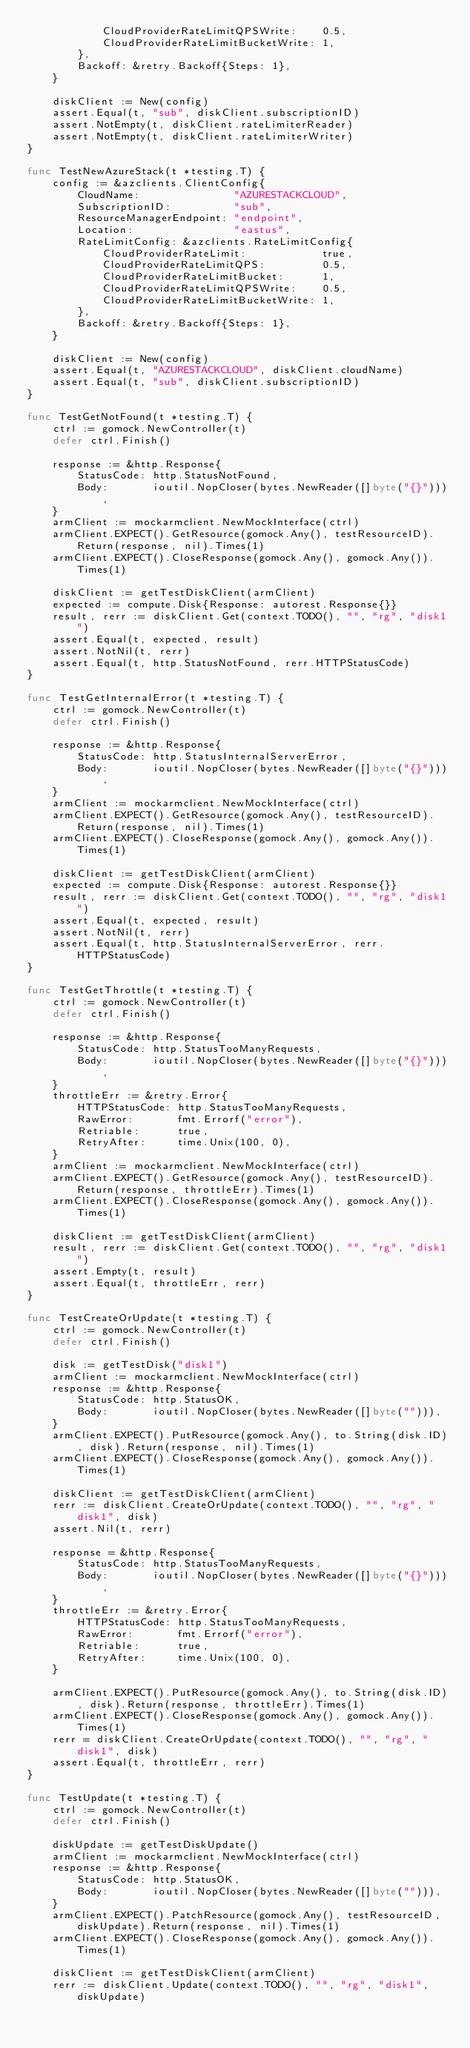<code> <loc_0><loc_0><loc_500><loc_500><_Go_>			CloudProviderRateLimitQPSWrite:    0.5,
			CloudProviderRateLimitBucketWrite: 1,
		},
		Backoff: &retry.Backoff{Steps: 1},
	}

	diskClient := New(config)
	assert.Equal(t, "sub", diskClient.subscriptionID)
	assert.NotEmpty(t, diskClient.rateLimiterReader)
	assert.NotEmpty(t, diskClient.rateLimiterWriter)
}

func TestNewAzureStack(t *testing.T) {
	config := &azclients.ClientConfig{
		CloudName:               "AZURESTACKCLOUD",
		SubscriptionID:          "sub",
		ResourceManagerEndpoint: "endpoint",
		Location:                "eastus",
		RateLimitConfig: &azclients.RateLimitConfig{
			CloudProviderRateLimit:            true,
			CloudProviderRateLimitQPS:         0.5,
			CloudProviderRateLimitBucket:      1,
			CloudProviderRateLimitQPSWrite:    0.5,
			CloudProviderRateLimitBucketWrite: 1,
		},
		Backoff: &retry.Backoff{Steps: 1},
	}

	diskClient := New(config)
	assert.Equal(t, "AZURESTACKCLOUD", diskClient.cloudName)
	assert.Equal(t, "sub", diskClient.subscriptionID)
}

func TestGetNotFound(t *testing.T) {
	ctrl := gomock.NewController(t)
	defer ctrl.Finish()

	response := &http.Response{
		StatusCode: http.StatusNotFound,
		Body:       ioutil.NopCloser(bytes.NewReader([]byte("{}"))),
	}
	armClient := mockarmclient.NewMockInterface(ctrl)
	armClient.EXPECT().GetResource(gomock.Any(), testResourceID).Return(response, nil).Times(1)
	armClient.EXPECT().CloseResponse(gomock.Any(), gomock.Any()).Times(1)

	diskClient := getTestDiskClient(armClient)
	expected := compute.Disk{Response: autorest.Response{}}
	result, rerr := diskClient.Get(context.TODO(), "", "rg", "disk1")
	assert.Equal(t, expected, result)
	assert.NotNil(t, rerr)
	assert.Equal(t, http.StatusNotFound, rerr.HTTPStatusCode)
}

func TestGetInternalError(t *testing.T) {
	ctrl := gomock.NewController(t)
	defer ctrl.Finish()

	response := &http.Response{
		StatusCode: http.StatusInternalServerError,
		Body:       ioutil.NopCloser(bytes.NewReader([]byte("{}"))),
	}
	armClient := mockarmclient.NewMockInterface(ctrl)
	armClient.EXPECT().GetResource(gomock.Any(), testResourceID).Return(response, nil).Times(1)
	armClient.EXPECT().CloseResponse(gomock.Any(), gomock.Any()).Times(1)

	diskClient := getTestDiskClient(armClient)
	expected := compute.Disk{Response: autorest.Response{}}
	result, rerr := diskClient.Get(context.TODO(), "", "rg", "disk1")
	assert.Equal(t, expected, result)
	assert.NotNil(t, rerr)
	assert.Equal(t, http.StatusInternalServerError, rerr.HTTPStatusCode)
}

func TestGetThrottle(t *testing.T) {
	ctrl := gomock.NewController(t)
	defer ctrl.Finish()

	response := &http.Response{
		StatusCode: http.StatusTooManyRequests,
		Body:       ioutil.NopCloser(bytes.NewReader([]byte("{}"))),
	}
	throttleErr := &retry.Error{
		HTTPStatusCode: http.StatusTooManyRequests,
		RawError:       fmt.Errorf("error"),
		Retriable:      true,
		RetryAfter:     time.Unix(100, 0),
	}
	armClient := mockarmclient.NewMockInterface(ctrl)
	armClient.EXPECT().GetResource(gomock.Any(), testResourceID).Return(response, throttleErr).Times(1)
	armClient.EXPECT().CloseResponse(gomock.Any(), gomock.Any()).Times(1)

	diskClient := getTestDiskClient(armClient)
	result, rerr := diskClient.Get(context.TODO(), "", "rg", "disk1")
	assert.Empty(t, result)
	assert.Equal(t, throttleErr, rerr)
}

func TestCreateOrUpdate(t *testing.T) {
	ctrl := gomock.NewController(t)
	defer ctrl.Finish()

	disk := getTestDisk("disk1")
	armClient := mockarmclient.NewMockInterface(ctrl)
	response := &http.Response{
		StatusCode: http.StatusOK,
		Body:       ioutil.NopCloser(bytes.NewReader([]byte(""))),
	}
	armClient.EXPECT().PutResource(gomock.Any(), to.String(disk.ID), disk).Return(response, nil).Times(1)
	armClient.EXPECT().CloseResponse(gomock.Any(), gomock.Any()).Times(1)

	diskClient := getTestDiskClient(armClient)
	rerr := diskClient.CreateOrUpdate(context.TODO(), "", "rg", "disk1", disk)
	assert.Nil(t, rerr)

	response = &http.Response{
		StatusCode: http.StatusTooManyRequests,
		Body:       ioutil.NopCloser(bytes.NewReader([]byte("{}"))),
	}
	throttleErr := &retry.Error{
		HTTPStatusCode: http.StatusTooManyRequests,
		RawError:       fmt.Errorf("error"),
		Retriable:      true,
		RetryAfter:     time.Unix(100, 0),
	}

	armClient.EXPECT().PutResource(gomock.Any(), to.String(disk.ID), disk).Return(response, throttleErr).Times(1)
	armClient.EXPECT().CloseResponse(gomock.Any(), gomock.Any()).Times(1)
	rerr = diskClient.CreateOrUpdate(context.TODO(), "", "rg", "disk1", disk)
	assert.Equal(t, throttleErr, rerr)
}

func TestUpdate(t *testing.T) {
	ctrl := gomock.NewController(t)
	defer ctrl.Finish()

	diskUpdate := getTestDiskUpdate()
	armClient := mockarmclient.NewMockInterface(ctrl)
	response := &http.Response{
		StatusCode: http.StatusOK,
		Body:       ioutil.NopCloser(bytes.NewReader([]byte(""))),
	}
	armClient.EXPECT().PatchResource(gomock.Any(), testResourceID, diskUpdate).Return(response, nil).Times(1)
	armClient.EXPECT().CloseResponse(gomock.Any(), gomock.Any()).Times(1)

	diskClient := getTestDiskClient(armClient)
	rerr := diskClient.Update(context.TODO(), "", "rg", "disk1", diskUpdate)</code> 